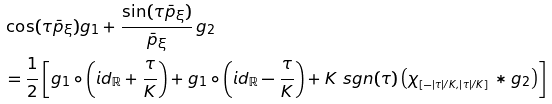<formula> <loc_0><loc_0><loc_500><loc_500>& \cos ( \tau \bar { p } _ { \xi } ) g _ { 1 } + \frac { \sin ( \tau \bar { p } _ { \xi } ) } { \bar { p } _ { \xi } } \, g _ { 2 } \\ & = \frac { 1 } { 2 } \left [ g _ { 1 } \circ \left ( { i d } _ { \mathbb { R } } + \frac { \tau } { K } \right ) + g _ { 1 } \circ \left ( { i d } _ { \mathbb { R } } - \frac { \tau } { K } \right ) + K \ s g n ( \tau ) \left ( \chi _ { _ { [ - | \tau | / K , | \tau | / K ] } } * g _ { 2 } \right ) \right ]</formula> 